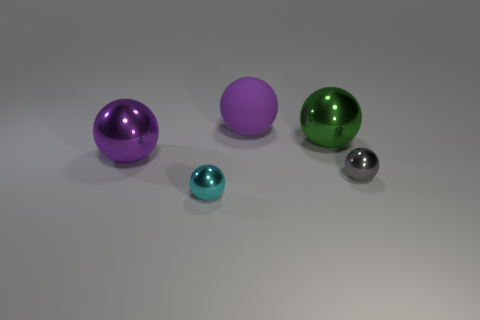How many rubber objects are either tiny blue blocks or big green objects?
Your answer should be compact. 0. There is a small object on the left side of the gray shiny ball; what number of large green shiny objects are on the left side of it?
Provide a succinct answer. 0. What is the material of the big purple thing that is right of the big purple sphere that is in front of the purple thing that is behind the green object?
Keep it short and to the point. Rubber. There is a metal object that is the same color as the big rubber object; what is its size?
Give a very brief answer. Large. What is the material of the green ball?
Provide a short and direct response. Metal. Does the large green ball have the same material as the tiny thing in front of the tiny gray thing?
Your answer should be compact. Yes. The tiny metallic thing right of the large ball that is on the right side of the purple matte thing is what color?
Offer a terse response. Gray. What size is the thing that is both in front of the purple metallic thing and left of the big purple rubber ball?
Offer a terse response. Small. What number of other things are there of the same shape as the cyan thing?
Keep it short and to the point. 4. Do the cyan metallic thing and the purple object in front of the big green metallic thing have the same shape?
Offer a very short reply. Yes. 